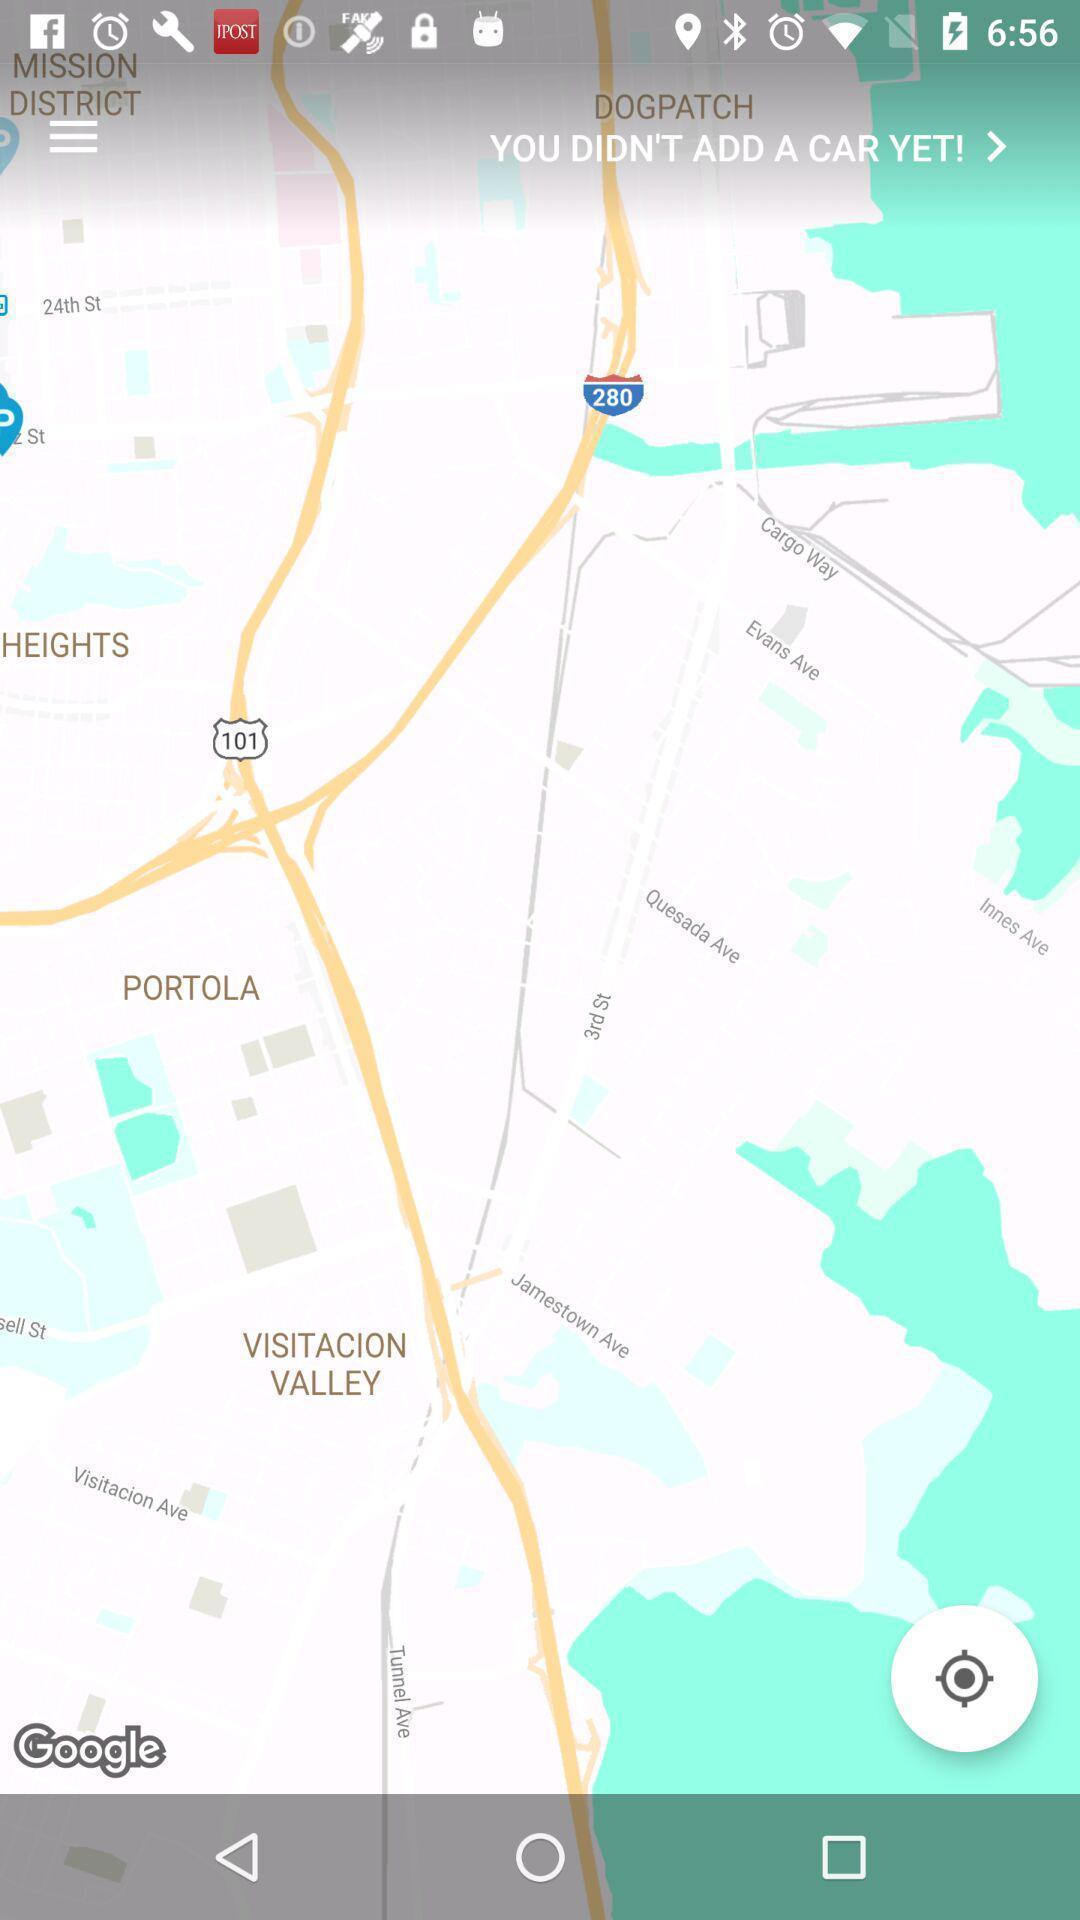What can you discern from this picture? Page showing route map of a location an locator app. 